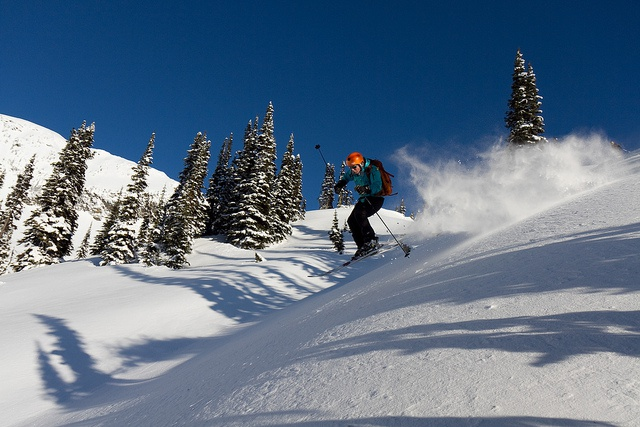Describe the objects in this image and their specific colors. I can see people in darkblue, black, blue, and maroon tones, backpack in darkblue, black, maroon, navy, and blue tones, and skis in darkblue, gray, and black tones in this image. 